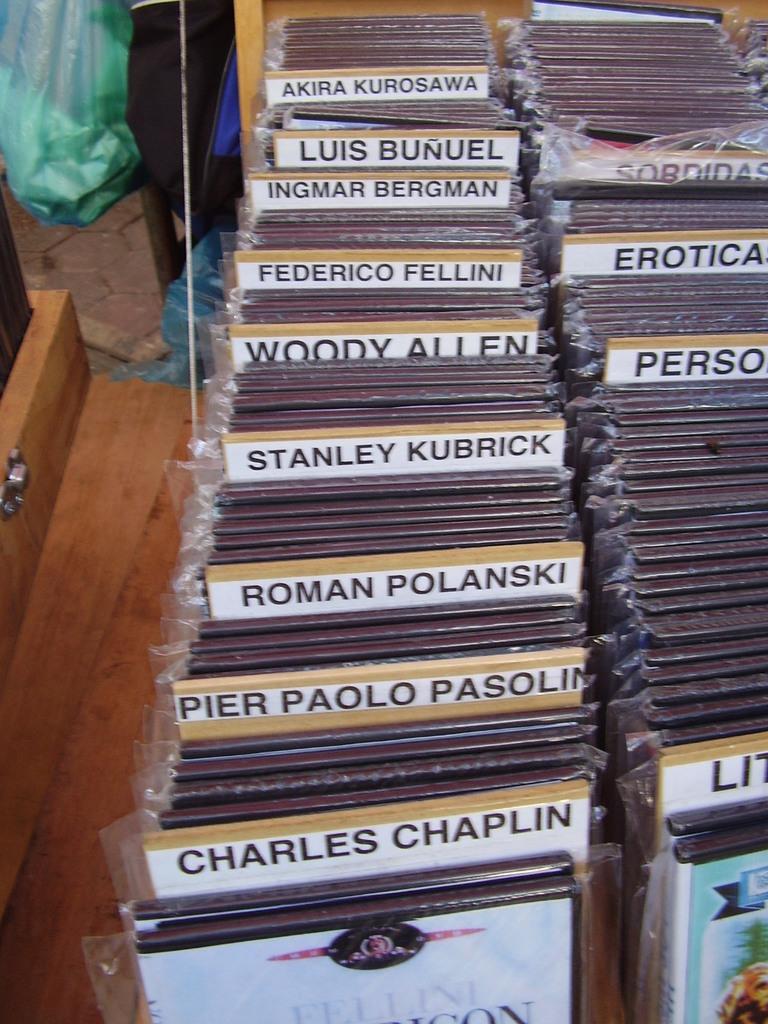Could you give a brief overview of what you see in this image? In this image I can see few boards, plastic covers and few objects around. 